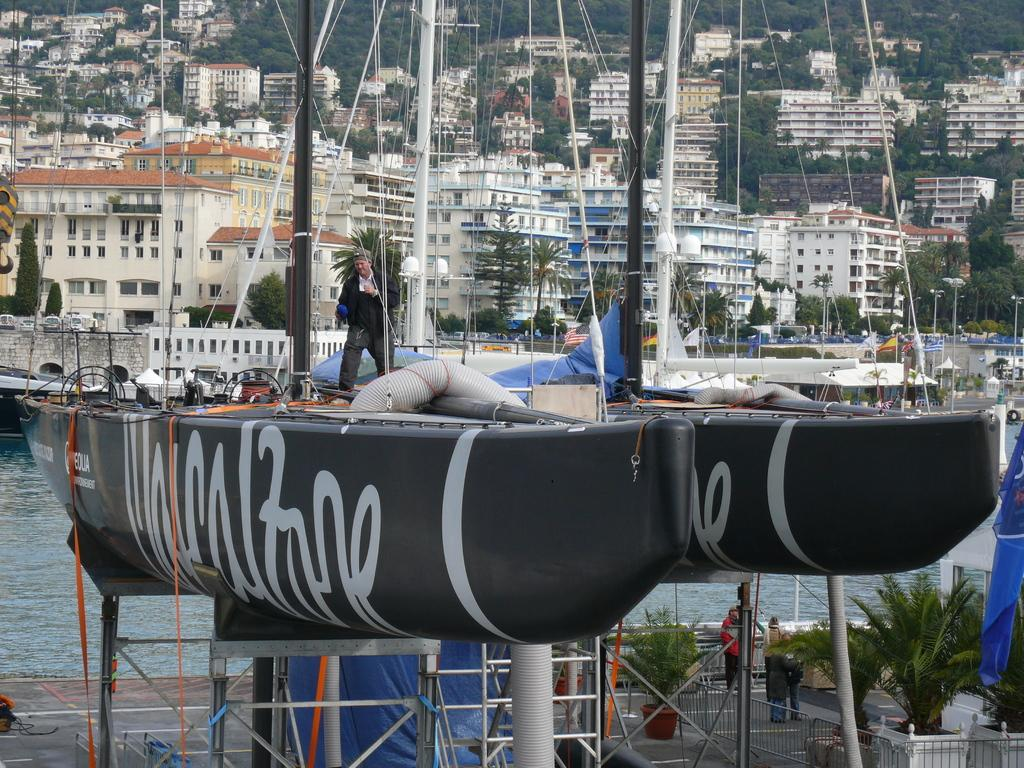What type of vehicles can be seen in the image? There are boats in the image. Can you describe the people in the image? There are people in the image. What kind of plant is located indoors in the image? There is a houseplant in the image. What type of vegetation is present in the image? There are plants in the image. What architectural feature can be seen in the image? There is a fence in the image. What natural element is visible in the image? Water is visible in the image. What else can be seen in the image besides the boats and people? There are objects in the image. What can be seen in the background of the image? There are buildings and trees in the background of the image. Where is the bedroom located in the image? There is no bedroom present in the image. What type of book is being read by the person in the image? There are no people reading a book in the image. 